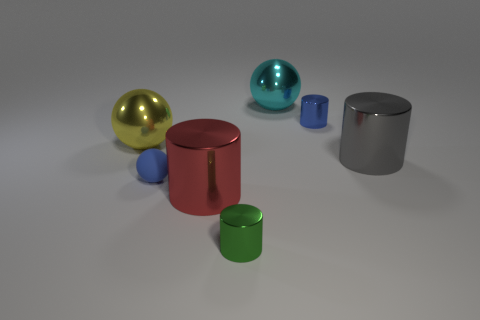Add 2 small green metallic cylinders. How many objects exist? 9 Subtract all cylinders. How many objects are left? 3 Add 7 small green objects. How many small green objects are left? 8 Add 5 green objects. How many green objects exist? 6 Subtract 0 cyan cylinders. How many objects are left? 7 Subtract all tiny metallic cylinders. Subtract all big spheres. How many objects are left? 3 